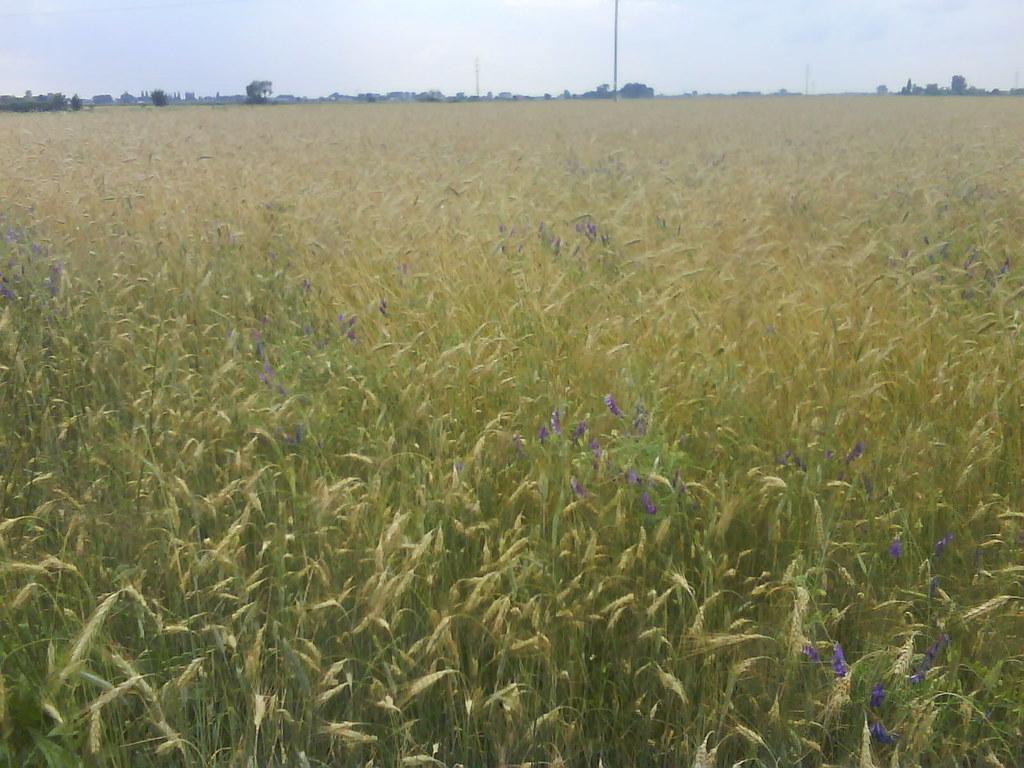How would you summarize this image in a sentence or two? In this image I can see few plants in green color, flowers in purple color. Background I can see few poles and the sky is in white color. 